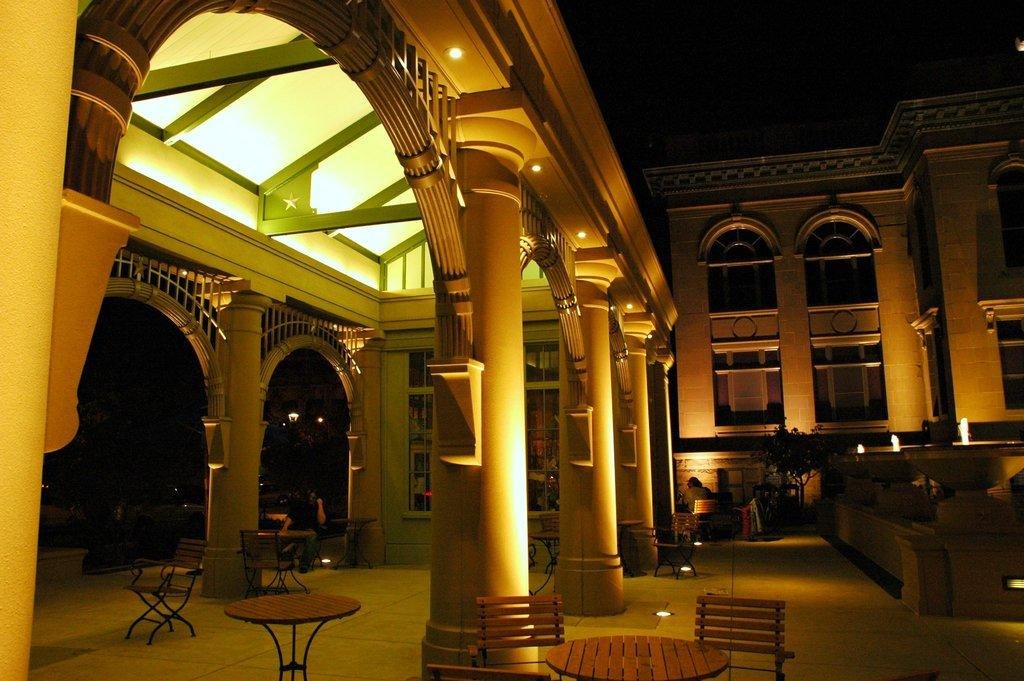What can be found in the middle of the image? In the middle of the image, there are pillars, lights, tables, and chairs. What is visible on the right side of the image? On the right side of the image, there are people, plants, lights, a building, and windows. What type of surface is visible in the image? A floor is visible in the image. How many horses are present on the coast in the image? There are no horses or coast present in the image. What angle do the lights make with the pillars in the image? The angle between the lights and pillars cannot be determined from the image, as it does not provide any information about the angle. 